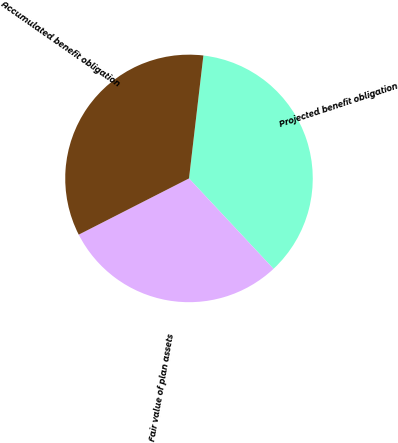Convert chart to OTSL. <chart><loc_0><loc_0><loc_500><loc_500><pie_chart><fcel>Projected benefit obligation<fcel>Fair value of plan assets<fcel>Accumulated benefit obligation<nl><fcel>36.18%<fcel>29.46%<fcel>34.36%<nl></chart> 